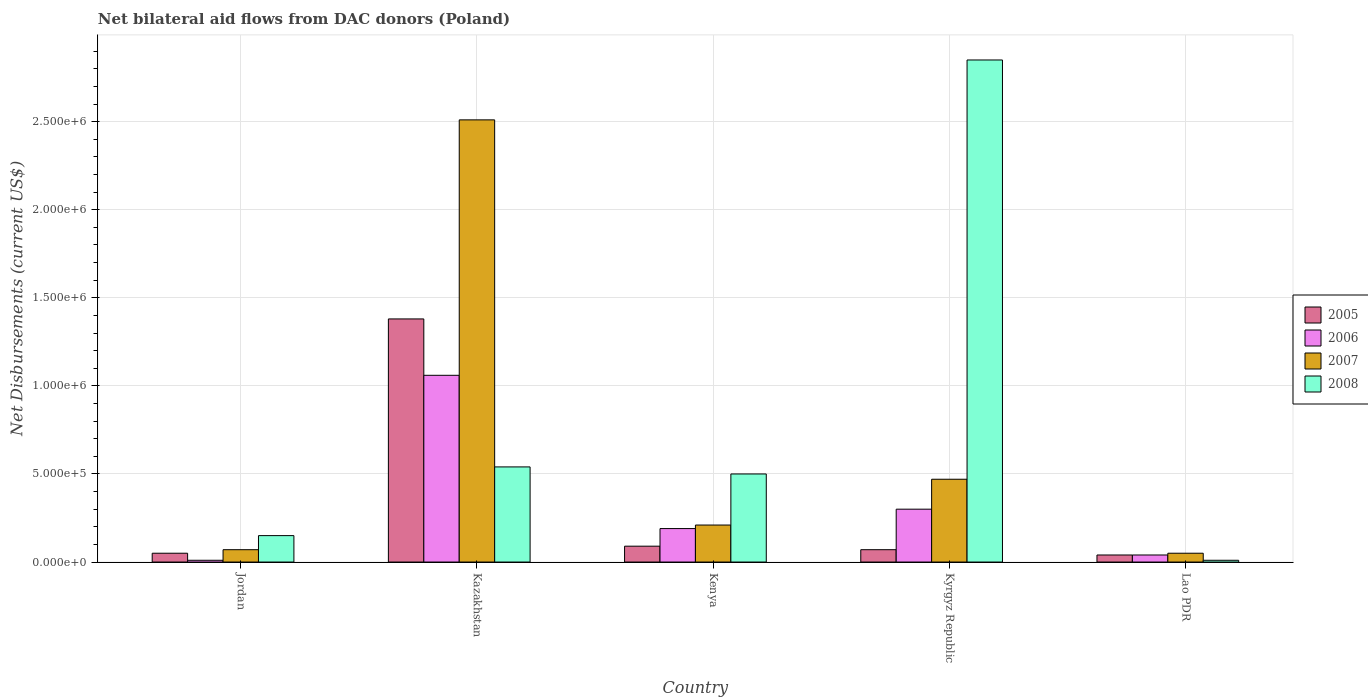How many different coloured bars are there?
Provide a succinct answer. 4. Are the number of bars per tick equal to the number of legend labels?
Offer a very short reply. Yes. How many bars are there on the 2nd tick from the left?
Offer a terse response. 4. How many bars are there on the 1st tick from the right?
Provide a succinct answer. 4. What is the label of the 1st group of bars from the left?
Give a very brief answer. Jordan. What is the net bilateral aid flows in 2005 in Lao PDR?
Provide a succinct answer. 4.00e+04. Across all countries, what is the maximum net bilateral aid flows in 2005?
Make the answer very short. 1.38e+06. In which country was the net bilateral aid flows in 2007 maximum?
Offer a very short reply. Kazakhstan. In which country was the net bilateral aid flows in 2006 minimum?
Offer a terse response. Jordan. What is the total net bilateral aid flows in 2006 in the graph?
Keep it short and to the point. 1.60e+06. What is the difference between the net bilateral aid flows in 2006 in Kenya and that in Kyrgyz Republic?
Make the answer very short. -1.10e+05. What is the difference between the net bilateral aid flows in 2007 in Kyrgyz Republic and the net bilateral aid flows in 2006 in Jordan?
Offer a terse response. 4.60e+05. What is the average net bilateral aid flows in 2005 per country?
Offer a very short reply. 3.26e+05. In how many countries, is the net bilateral aid flows in 2006 greater than 2200000 US$?
Ensure brevity in your answer.  0. What is the ratio of the net bilateral aid flows in 2007 in Jordan to that in Kazakhstan?
Give a very brief answer. 0.03. Is the difference between the net bilateral aid flows in 2008 in Kazakhstan and Kenya greater than the difference between the net bilateral aid flows in 2006 in Kazakhstan and Kenya?
Your response must be concise. No. What is the difference between the highest and the second highest net bilateral aid flows in 2008?
Give a very brief answer. 2.35e+06. What is the difference between the highest and the lowest net bilateral aid flows in 2005?
Provide a short and direct response. 1.34e+06. Is it the case that in every country, the sum of the net bilateral aid flows in 2006 and net bilateral aid flows in 2005 is greater than the net bilateral aid flows in 2008?
Give a very brief answer. No. Are all the bars in the graph horizontal?
Provide a short and direct response. No. How many countries are there in the graph?
Your answer should be very brief. 5. What is the difference between two consecutive major ticks on the Y-axis?
Ensure brevity in your answer.  5.00e+05. Where does the legend appear in the graph?
Offer a terse response. Center right. How are the legend labels stacked?
Your answer should be compact. Vertical. What is the title of the graph?
Your response must be concise. Net bilateral aid flows from DAC donors (Poland). Does "1987" appear as one of the legend labels in the graph?
Your answer should be very brief. No. What is the label or title of the Y-axis?
Your answer should be compact. Net Disbursements (current US$). What is the Net Disbursements (current US$) of 2007 in Jordan?
Keep it short and to the point. 7.00e+04. What is the Net Disbursements (current US$) in 2008 in Jordan?
Your answer should be very brief. 1.50e+05. What is the Net Disbursements (current US$) in 2005 in Kazakhstan?
Keep it short and to the point. 1.38e+06. What is the Net Disbursements (current US$) of 2006 in Kazakhstan?
Your answer should be compact. 1.06e+06. What is the Net Disbursements (current US$) of 2007 in Kazakhstan?
Provide a short and direct response. 2.51e+06. What is the Net Disbursements (current US$) of 2008 in Kazakhstan?
Offer a terse response. 5.40e+05. What is the Net Disbursements (current US$) of 2005 in Kenya?
Ensure brevity in your answer.  9.00e+04. What is the Net Disbursements (current US$) of 2008 in Kenya?
Your answer should be very brief. 5.00e+05. What is the Net Disbursements (current US$) in 2008 in Kyrgyz Republic?
Make the answer very short. 2.85e+06. What is the Net Disbursements (current US$) of 2007 in Lao PDR?
Your answer should be compact. 5.00e+04. What is the Net Disbursements (current US$) in 2008 in Lao PDR?
Keep it short and to the point. 10000. Across all countries, what is the maximum Net Disbursements (current US$) of 2005?
Offer a terse response. 1.38e+06. Across all countries, what is the maximum Net Disbursements (current US$) in 2006?
Make the answer very short. 1.06e+06. Across all countries, what is the maximum Net Disbursements (current US$) in 2007?
Provide a succinct answer. 2.51e+06. Across all countries, what is the maximum Net Disbursements (current US$) in 2008?
Make the answer very short. 2.85e+06. Across all countries, what is the minimum Net Disbursements (current US$) in 2006?
Give a very brief answer. 10000. Across all countries, what is the minimum Net Disbursements (current US$) of 2007?
Offer a very short reply. 5.00e+04. Across all countries, what is the minimum Net Disbursements (current US$) of 2008?
Offer a terse response. 10000. What is the total Net Disbursements (current US$) of 2005 in the graph?
Make the answer very short. 1.63e+06. What is the total Net Disbursements (current US$) of 2006 in the graph?
Keep it short and to the point. 1.60e+06. What is the total Net Disbursements (current US$) of 2007 in the graph?
Give a very brief answer. 3.31e+06. What is the total Net Disbursements (current US$) in 2008 in the graph?
Keep it short and to the point. 4.05e+06. What is the difference between the Net Disbursements (current US$) of 2005 in Jordan and that in Kazakhstan?
Make the answer very short. -1.33e+06. What is the difference between the Net Disbursements (current US$) in 2006 in Jordan and that in Kazakhstan?
Keep it short and to the point. -1.05e+06. What is the difference between the Net Disbursements (current US$) of 2007 in Jordan and that in Kazakhstan?
Provide a succinct answer. -2.44e+06. What is the difference between the Net Disbursements (current US$) in 2008 in Jordan and that in Kazakhstan?
Your answer should be compact. -3.90e+05. What is the difference between the Net Disbursements (current US$) of 2007 in Jordan and that in Kenya?
Ensure brevity in your answer.  -1.40e+05. What is the difference between the Net Disbursements (current US$) in 2008 in Jordan and that in Kenya?
Make the answer very short. -3.50e+05. What is the difference between the Net Disbursements (current US$) in 2005 in Jordan and that in Kyrgyz Republic?
Offer a very short reply. -2.00e+04. What is the difference between the Net Disbursements (current US$) of 2007 in Jordan and that in Kyrgyz Republic?
Ensure brevity in your answer.  -4.00e+05. What is the difference between the Net Disbursements (current US$) of 2008 in Jordan and that in Kyrgyz Republic?
Provide a short and direct response. -2.70e+06. What is the difference between the Net Disbursements (current US$) of 2008 in Jordan and that in Lao PDR?
Your answer should be very brief. 1.40e+05. What is the difference between the Net Disbursements (current US$) in 2005 in Kazakhstan and that in Kenya?
Ensure brevity in your answer.  1.29e+06. What is the difference between the Net Disbursements (current US$) of 2006 in Kazakhstan and that in Kenya?
Give a very brief answer. 8.70e+05. What is the difference between the Net Disbursements (current US$) of 2007 in Kazakhstan and that in Kenya?
Your answer should be very brief. 2.30e+06. What is the difference between the Net Disbursements (current US$) of 2008 in Kazakhstan and that in Kenya?
Make the answer very short. 4.00e+04. What is the difference between the Net Disbursements (current US$) of 2005 in Kazakhstan and that in Kyrgyz Republic?
Keep it short and to the point. 1.31e+06. What is the difference between the Net Disbursements (current US$) in 2006 in Kazakhstan and that in Kyrgyz Republic?
Your response must be concise. 7.60e+05. What is the difference between the Net Disbursements (current US$) in 2007 in Kazakhstan and that in Kyrgyz Republic?
Offer a very short reply. 2.04e+06. What is the difference between the Net Disbursements (current US$) in 2008 in Kazakhstan and that in Kyrgyz Republic?
Provide a succinct answer. -2.31e+06. What is the difference between the Net Disbursements (current US$) of 2005 in Kazakhstan and that in Lao PDR?
Provide a short and direct response. 1.34e+06. What is the difference between the Net Disbursements (current US$) of 2006 in Kazakhstan and that in Lao PDR?
Keep it short and to the point. 1.02e+06. What is the difference between the Net Disbursements (current US$) in 2007 in Kazakhstan and that in Lao PDR?
Keep it short and to the point. 2.46e+06. What is the difference between the Net Disbursements (current US$) of 2008 in Kazakhstan and that in Lao PDR?
Offer a very short reply. 5.30e+05. What is the difference between the Net Disbursements (current US$) of 2005 in Kenya and that in Kyrgyz Republic?
Make the answer very short. 2.00e+04. What is the difference between the Net Disbursements (current US$) of 2008 in Kenya and that in Kyrgyz Republic?
Offer a terse response. -2.35e+06. What is the difference between the Net Disbursements (current US$) of 2006 in Kenya and that in Lao PDR?
Your response must be concise. 1.50e+05. What is the difference between the Net Disbursements (current US$) in 2008 in Kenya and that in Lao PDR?
Give a very brief answer. 4.90e+05. What is the difference between the Net Disbursements (current US$) of 2007 in Kyrgyz Republic and that in Lao PDR?
Your answer should be compact. 4.20e+05. What is the difference between the Net Disbursements (current US$) of 2008 in Kyrgyz Republic and that in Lao PDR?
Keep it short and to the point. 2.84e+06. What is the difference between the Net Disbursements (current US$) of 2005 in Jordan and the Net Disbursements (current US$) of 2006 in Kazakhstan?
Provide a succinct answer. -1.01e+06. What is the difference between the Net Disbursements (current US$) of 2005 in Jordan and the Net Disbursements (current US$) of 2007 in Kazakhstan?
Make the answer very short. -2.46e+06. What is the difference between the Net Disbursements (current US$) in 2005 in Jordan and the Net Disbursements (current US$) in 2008 in Kazakhstan?
Offer a very short reply. -4.90e+05. What is the difference between the Net Disbursements (current US$) in 2006 in Jordan and the Net Disbursements (current US$) in 2007 in Kazakhstan?
Your answer should be very brief. -2.50e+06. What is the difference between the Net Disbursements (current US$) in 2006 in Jordan and the Net Disbursements (current US$) in 2008 in Kazakhstan?
Keep it short and to the point. -5.30e+05. What is the difference between the Net Disbursements (current US$) of 2007 in Jordan and the Net Disbursements (current US$) of 2008 in Kazakhstan?
Keep it short and to the point. -4.70e+05. What is the difference between the Net Disbursements (current US$) of 2005 in Jordan and the Net Disbursements (current US$) of 2006 in Kenya?
Offer a terse response. -1.40e+05. What is the difference between the Net Disbursements (current US$) of 2005 in Jordan and the Net Disbursements (current US$) of 2008 in Kenya?
Ensure brevity in your answer.  -4.50e+05. What is the difference between the Net Disbursements (current US$) in 2006 in Jordan and the Net Disbursements (current US$) in 2007 in Kenya?
Offer a terse response. -2.00e+05. What is the difference between the Net Disbursements (current US$) in 2006 in Jordan and the Net Disbursements (current US$) in 2008 in Kenya?
Make the answer very short. -4.90e+05. What is the difference between the Net Disbursements (current US$) in 2007 in Jordan and the Net Disbursements (current US$) in 2008 in Kenya?
Make the answer very short. -4.30e+05. What is the difference between the Net Disbursements (current US$) of 2005 in Jordan and the Net Disbursements (current US$) of 2006 in Kyrgyz Republic?
Keep it short and to the point. -2.50e+05. What is the difference between the Net Disbursements (current US$) of 2005 in Jordan and the Net Disbursements (current US$) of 2007 in Kyrgyz Republic?
Provide a short and direct response. -4.20e+05. What is the difference between the Net Disbursements (current US$) in 2005 in Jordan and the Net Disbursements (current US$) in 2008 in Kyrgyz Republic?
Provide a short and direct response. -2.80e+06. What is the difference between the Net Disbursements (current US$) in 2006 in Jordan and the Net Disbursements (current US$) in 2007 in Kyrgyz Republic?
Offer a very short reply. -4.60e+05. What is the difference between the Net Disbursements (current US$) in 2006 in Jordan and the Net Disbursements (current US$) in 2008 in Kyrgyz Republic?
Give a very brief answer. -2.84e+06. What is the difference between the Net Disbursements (current US$) of 2007 in Jordan and the Net Disbursements (current US$) of 2008 in Kyrgyz Republic?
Make the answer very short. -2.78e+06. What is the difference between the Net Disbursements (current US$) in 2005 in Jordan and the Net Disbursements (current US$) in 2006 in Lao PDR?
Provide a short and direct response. 10000. What is the difference between the Net Disbursements (current US$) in 2005 in Jordan and the Net Disbursements (current US$) in 2007 in Lao PDR?
Offer a very short reply. 0. What is the difference between the Net Disbursements (current US$) in 2005 in Jordan and the Net Disbursements (current US$) in 2008 in Lao PDR?
Your response must be concise. 4.00e+04. What is the difference between the Net Disbursements (current US$) in 2006 in Jordan and the Net Disbursements (current US$) in 2007 in Lao PDR?
Your answer should be compact. -4.00e+04. What is the difference between the Net Disbursements (current US$) of 2007 in Jordan and the Net Disbursements (current US$) of 2008 in Lao PDR?
Provide a short and direct response. 6.00e+04. What is the difference between the Net Disbursements (current US$) in 2005 in Kazakhstan and the Net Disbursements (current US$) in 2006 in Kenya?
Ensure brevity in your answer.  1.19e+06. What is the difference between the Net Disbursements (current US$) of 2005 in Kazakhstan and the Net Disbursements (current US$) of 2007 in Kenya?
Your answer should be very brief. 1.17e+06. What is the difference between the Net Disbursements (current US$) of 2005 in Kazakhstan and the Net Disbursements (current US$) of 2008 in Kenya?
Offer a very short reply. 8.80e+05. What is the difference between the Net Disbursements (current US$) in 2006 in Kazakhstan and the Net Disbursements (current US$) in 2007 in Kenya?
Make the answer very short. 8.50e+05. What is the difference between the Net Disbursements (current US$) of 2006 in Kazakhstan and the Net Disbursements (current US$) of 2008 in Kenya?
Ensure brevity in your answer.  5.60e+05. What is the difference between the Net Disbursements (current US$) in 2007 in Kazakhstan and the Net Disbursements (current US$) in 2008 in Kenya?
Provide a short and direct response. 2.01e+06. What is the difference between the Net Disbursements (current US$) of 2005 in Kazakhstan and the Net Disbursements (current US$) of 2006 in Kyrgyz Republic?
Offer a terse response. 1.08e+06. What is the difference between the Net Disbursements (current US$) of 2005 in Kazakhstan and the Net Disbursements (current US$) of 2007 in Kyrgyz Republic?
Offer a very short reply. 9.10e+05. What is the difference between the Net Disbursements (current US$) in 2005 in Kazakhstan and the Net Disbursements (current US$) in 2008 in Kyrgyz Republic?
Keep it short and to the point. -1.47e+06. What is the difference between the Net Disbursements (current US$) in 2006 in Kazakhstan and the Net Disbursements (current US$) in 2007 in Kyrgyz Republic?
Offer a terse response. 5.90e+05. What is the difference between the Net Disbursements (current US$) of 2006 in Kazakhstan and the Net Disbursements (current US$) of 2008 in Kyrgyz Republic?
Make the answer very short. -1.79e+06. What is the difference between the Net Disbursements (current US$) in 2007 in Kazakhstan and the Net Disbursements (current US$) in 2008 in Kyrgyz Republic?
Offer a terse response. -3.40e+05. What is the difference between the Net Disbursements (current US$) in 2005 in Kazakhstan and the Net Disbursements (current US$) in 2006 in Lao PDR?
Provide a succinct answer. 1.34e+06. What is the difference between the Net Disbursements (current US$) of 2005 in Kazakhstan and the Net Disbursements (current US$) of 2007 in Lao PDR?
Provide a succinct answer. 1.33e+06. What is the difference between the Net Disbursements (current US$) in 2005 in Kazakhstan and the Net Disbursements (current US$) in 2008 in Lao PDR?
Your answer should be very brief. 1.37e+06. What is the difference between the Net Disbursements (current US$) in 2006 in Kazakhstan and the Net Disbursements (current US$) in 2007 in Lao PDR?
Your answer should be compact. 1.01e+06. What is the difference between the Net Disbursements (current US$) in 2006 in Kazakhstan and the Net Disbursements (current US$) in 2008 in Lao PDR?
Give a very brief answer. 1.05e+06. What is the difference between the Net Disbursements (current US$) of 2007 in Kazakhstan and the Net Disbursements (current US$) of 2008 in Lao PDR?
Give a very brief answer. 2.50e+06. What is the difference between the Net Disbursements (current US$) in 2005 in Kenya and the Net Disbursements (current US$) in 2006 in Kyrgyz Republic?
Make the answer very short. -2.10e+05. What is the difference between the Net Disbursements (current US$) of 2005 in Kenya and the Net Disbursements (current US$) of 2007 in Kyrgyz Republic?
Your answer should be compact. -3.80e+05. What is the difference between the Net Disbursements (current US$) in 2005 in Kenya and the Net Disbursements (current US$) in 2008 in Kyrgyz Republic?
Provide a short and direct response. -2.76e+06. What is the difference between the Net Disbursements (current US$) of 2006 in Kenya and the Net Disbursements (current US$) of 2007 in Kyrgyz Republic?
Your response must be concise. -2.80e+05. What is the difference between the Net Disbursements (current US$) of 2006 in Kenya and the Net Disbursements (current US$) of 2008 in Kyrgyz Republic?
Ensure brevity in your answer.  -2.66e+06. What is the difference between the Net Disbursements (current US$) in 2007 in Kenya and the Net Disbursements (current US$) in 2008 in Kyrgyz Republic?
Ensure brevity in your answer.  -2.64e+06. What is the difference between the Net Disbursements (current US$) in 2006 in Kenya and the Net Disbursements (current US$) in 2008 in Lao PDR?
Provide a short and direct response. 1.80e+05. What is the difference between the Net Disbursements (current US$) of 2005 in Kyrgyz Republic and the Net Disbursements (current US$) of 2008 in Lao PDR?
Your answer should be compact. 6.00e+04. What is the difference between the Net Disbursements (current US$) in 2006 in Kyrgyz Republic and the Net Disbursements (current US$) in 2007 in Lao PDR?
Offer a very short reply. 2.50e+05. What is the average Net Disbursements (current US$) of 2005 per country?
Provide a short and direct response. 3.26e+05. What is the average Net Disbursements (current US$) of 2006 per country?
Your response must be concise. 3.20e+05. What is the average Net Disbursements (current US$) in 2007 per country?
Keep it short and to the point. 6.62e+05. What is the average Net Disbursements (current US$) in 2008 per country?
Your response must be concise. 8.10e+05. What is the difference between the Net Disbursements (current US$) in 2005 and Net Disbursements (current US$) in 2006 in Jordan?
Your response must be concise. 4.00e+04. What is the difference between the Net Disbursements (current US$) in 2005 and Net Disbursements (current US$) in 2007 in Jordan?
Your answer should be compact. -2.00e+04. What is the difference between the Net Disbursements (current US$) of 2005 and Net Disbursements (current US$) of 2008 in Jordan?
Provide a short and direct response. -1.00e+05. What is the difference between the Net Disbursements (current US$) in 2006 and Net Disbursements (current US$) in 2008 in Jordan?
Ensure brevity in your answer.  -1.40e+05. What is the difference between the Net Disbursements (current US$) in 2007 and Net Disbursements (current US$) in 2008 in Jordan?
Offer a very short reply. -8.00e+04. What is the difference between the Net Disbursements (current US$) in 2005 and Net Disbursements (current US$) in 2007 in Kazakhstan?
Offer a terse response. -1.13e+06. What is the difference between the Net Disbursements (current US$) of 2005 and Net Disbursements (current US$) of 2008 in Kazakhstan?
Provide a succinct answer. 8.40e+05. What is the difference between the Net Disbursements (current US$) of 2006 and Net Disbursements (current US$) of 2007 in Kazakhstan?
Provide a short and direct response. -1.45e+06. What is the difference between the Net Disbursements (current US$) in 2006 and Net Disbursements (current US$) in 2008 in Kazakhstan?
Your answer should be compact. 5.20e+05. What is the difference between the Net Disbursements (current US$) in 2007 and Net Disbursements (current US$) in 2008 in Kazakhstan?
Provide a succinct answer. 1.97e+06. What is the difference between the Net Disbursements (current US$) in 2005 and Net Disbursements (current US$) in 2006 in Kenya?
Give a very brief answer. -1.00e+05. What is the difference between the Net Disbursements (current US$) in 2005 and Net Disbursements (current US$) in 2007 in Kenya?
Provide a succinct answer. -1.20e+05. What is the difference between the Net Disbursements (current US$) in 2005 and Net Disbursements (current US$) in 2008 in Kenya?
Provide a short and direct response. -4.10e+05. What is the difference between the Net Disbursements (current US$) of 2006 and Net Disbursements (current US$) of 2008 in Kenya?
Give a very brief answer. -3.10e+05. What is the difference between the Net Disbursements (current US$) in 2005 and Net Disbursements (current US$) in 2006 in Kyrgyz Republic?
Give a very brief answer. -2.30e+05. What is the difference between the Net Disbursements (current US$) in 2005 and Net Disbursements (current US$) in 2007 in Kyrgyz Republic?
Ensure brevity in your answer.  -4.00e+05. What is the difference between the Net Disbursements (current US$) of 2005 and Net Disbursements (current US$) of 2008 in Kyrgyz Republic?
Offer a terse response. -2.78e+06. What is the difference between the Net Disbursements (current US$) of 2006 and Net Disbursements (current US$) of 2008 in Kyrgyz Republic?
Give a very brief answer. -2.55e+06. What is the difference between the Net Disbursements (current US$) of 2007 and Net Disbursements (current US$) of 2008 in Kyrgyz Republic?
Ensure brevity in your answer.  -2.38e+06. What is the difference between the Net Disbursements (current US$) in 2005 and Net Disbursements (current US$) in 2007 in Lao PDR?
Provide a succinct answer. -10000. What is the difference between the Net Disbursements (current US$) in 2006 and Net Disbursements (current US$) in 2007 in Lao PDR?
Give a very brief answer. -10000. What is the difference between the Net Disbursements (current US$) of 2006 and Net Disbursements (current US$) of 2008 in Lao PDR?
Offer a terse response. 3.00e+04. What is the difference between the Net Disbursements (current US$) in 2007 and Net Disbursements (current US$) in 2008 in Lao PDR?
Your answer should be compact. 4.00e+04. What is the ratio of the Net Disbursements (current US$) of 2005 in Jordan to that in Kazakhstan?
Your answer should be very brief. 0.04. What is the ratio of the Net Disbursements (current US$) of 2006 in Jordan to that in Kazakhstan?
Provide a short and direct response. 0.01. What is the ratio of the Net Disbursements (current US$) of 2007 in Jordan to that in Kazakhstan?
Your answer should be compact. 0.03. What is the ratio of the Net Disbursements (current US$) in 2008 in Jordan to that in Kazakhstan?
Offer a terse response. 0.28. What is the ratio of the Net Disbursements (current US$) of 2005 in Jordan to that in Kenya?
Your response must be concise. 0.56. What is the ratio of the Net Disbursements (current US$) of 2006 in Jordan to that in Kenya?
Your answer should be compact. 0.05. What is the ratio of the Net Disbursements (current US$) of 2008 in Jordan to that in Kenya?
Provide a short and direct response. 0.3. What is the ratio of the Net Disbursements (current US$) of 2005 in Jordan to that in Kyrgyz Republic?
Offer a very short reply. 0.71. What is the ratio of the Net Disbursements (current US$) of 2007 in Jordan to that in Kyrgyz Republic?
Your response must be concise. 0.15. What is the ratio of the Net Disbursements (current US$) in 2008 in Jordan to that in Kyrgyz Republic?
Keep it short and to the point. 0.05. What is the ratio of the Net Disbursements (current US$) of 2005 in Jordan to that in Lao PDR?
Ensure brevity in your answer.  1.25. What is the ratio of the Net Disbursements (current US$) in 2006 in Jordan to that in Lao PDR?
Keep it short and to the point. 0.25. What is the ratio of the Net Disbursements (current US$) in 2005 in Kazakhstan to that in Kenya?
Ensure brevity in your answer.  15.33. What is the ratio of the Net Disbursements (current US$) in 2006 in Kazakhstan to that in Kenya?
Your answer should be compact. 5.58. What is the ratio of the Net Disbursements (current US$) in 2007 in Kazakhstan to that in Kenya?
Give a very brief answer. 11.95. What is the ratio of the Net Disbursements (current US$) in 2005 in Kazakhstan to that in Kyrgyz Republic?
Keep it short and to the point. 19.71. What is the ratio of the Net Disbursements (current US$) of 2006 in Kazakhstan to that in Kyrgyz Republic?
Keep it short and to the point. 3.53. What is the ratio of the Net Disbursements (current US$) of 2007 in Kazakhstan to that in Kyrgyz Republic?
Offer a very short reply. 5.34. What is the ratio of the Net Disbursements (current US$) in 2008 in Kazakhstan to that in Kyrgyz Republic?
Your answer should be compact. 0.19. What is the ratio of the Net Disbursements (current US$) of 2005 in Kazakhstan to that in Lao PDR?
Your answer should be very brief. 34.5. What is the ratio of the Net Disbursements (current US$) in 2007 in Kazakhstan to that in Lao PDR?
Offer a very short reply. 50.2. What is the ratio of the Net Disbursements (current US$) in 2008 in Kazakhstan to that in Lao PDR?
Keep it short and to the point. 54. What is the ratio of the Net Disbursements (current US$) in 2006 in Kenya to that in Kyrgyz Republic?
Make the answer very short. 0.63. What is the ratio of the Net Disbursements (current US$) in 2007 in Kenya to that in Kyrgyz Republic?
Provide a succinct answer. 0.45. What is the ratio of the Net Disbursements (current US$) of 2008 in Kenya to that in Kyrgyz Republic?
Offer a very short reply. 0.18. What is the ratio of the Net Disbursements (current US$) in 2005 in Kenya to that in Lao PDR?
Your response must be concise. 2.25. What is the ratio of the Net Disbursements (current US$) in 2006 in Kenya to that in Lao PDR?
Give a very brief answer. 4.75. What is the ratio of the Net Disbursements (current US$) of 2007 in Kenya to that in Lao PDR?
Make the answer very short. 4.2. What is the ratio of the Net Disbursements (current US$) of 2005 in Kyrgyz Republic to that in Lao PDR?
Your answer should be compact. 1.75. What is the ratio of the Net Disbursements (current US$) of 2007 in Kyrgyz Republic to that in Lao PDR?
Ensure brevity in your answer.  9.4. What is the ratio of the Net Disbursements (current US$) of 2008 in Kyrgyz Republic to that in Lao PDR?
Your response must be concise. 285. What is the difference between the highest and the second highest Net Disbursements (current US$) of 2005?
Your answer should be compact. 1.29e+06. What is the difference between the highest and the second highest Net Disbursements (current US$) of 2006?
Offer a very short reply. 7.60e+05. What is the difference between the highest and the second highest Net Disbursements (current US$) in 2007?
Your answer should be very brief. 2.04e+06. What is the difference between the highest and the second highest Net Disbursements (current US$) of 2008?
Provide a succinct answer. 2.31e+06. What is the difference between the highest and the lowest Net Disbursements (current US$) of 2005?
Provide a succinct answer. 1.34e+06. What is the difference between the highest and the lowest Net Disbursements (current US$) in 2006?
Ensure brevity in your answer.  1.05e+06. What is the difference between the highest and the lowest Net Disbursements (current US$) in 2007?
Your response must be concise. 2.46e+06. What is the difference between the highest and the lowest Net Disbursements (current US$) in 2008?
Provide a succinct answer. 2.84e+06. 